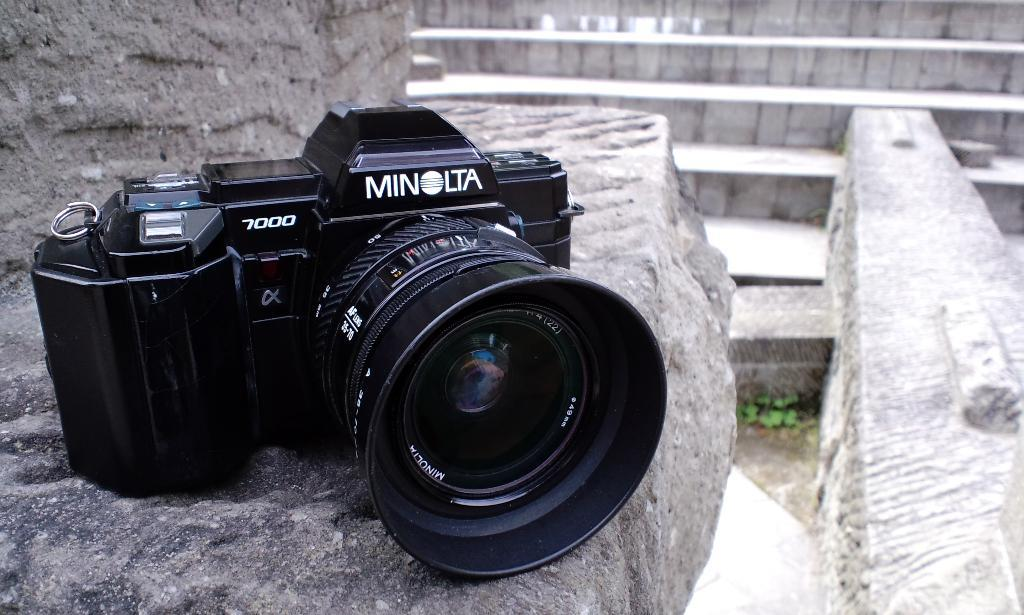What object is placed on a rock in the image? There is a camera on a rock in the image. What architectural feature can be seen at the back of the image? There is a staircase at the back of the image. What type of structure is present in the image? There is a wall in the image. What type of vegetation is visible on the ground in the image? There is a plant on the ground in the image. What type of education can be seen in the image? There is no reference to education in the image; it features a camera on a rock, a staircase, a wall, and a plant. 